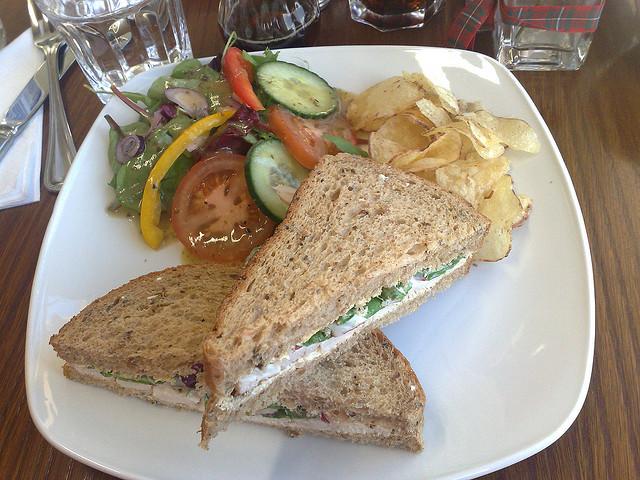Has this sandwich been tested yet?
Concise answer only. No. Where is the sandwich?
Quick response, please. On plate. How many pieces is the sandwich cut into?
Write a very short answer. 2. Is the bread toaster?
Write a very short answer. No. What is in the sandwich?
Short answer required. Chicken. 